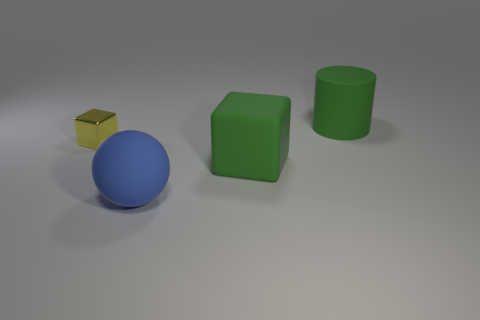There is a large object to the right of the green block; what is it made of?
Offer a very short reply. Rubber. What is the size of the block behind the large green cube to the right of the object that is on the left side of the blue ball?
Your response must be concise. Small. Does the block that is left of the sphere have the same material as the large green thing that is in front of the big rubber cylinder?
Your answer should be very brief. No. What number of other things are the same color as the big block?
Give a very brief answer. 1. How many objects are rubber things that are in front of the small yellow metal block or large objects behind the yellow cube?
Make the answer very short. 3. There is a green object left of the big thing that is behind the tiny yellow cube; how big is it?
Provide a short and direct response. Large. How big is the metal object?
Provide a short and direct response. Small. There is a big rubber thing that is in front of the green matte cube; is its color the same as the matte thing behind the yellow metallic cube?
Offer a terse response. No. What number of other things are there of the same material as the large blue sphere
Offer a very short reply. 2. Is there a big matte cylinder?
Keep it short and to the point. Yes. 